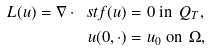<formula> <loc_0><loc_0><loc_500><loc_500>L ( u ) = \nabla \cdot \ s t f ( u ) & = 0 \text { in } \, Q _ { T } , \\ u ( 0 , \cdot ) & = u _ { 0 } \text { on } \, \Omega ,</formula> 